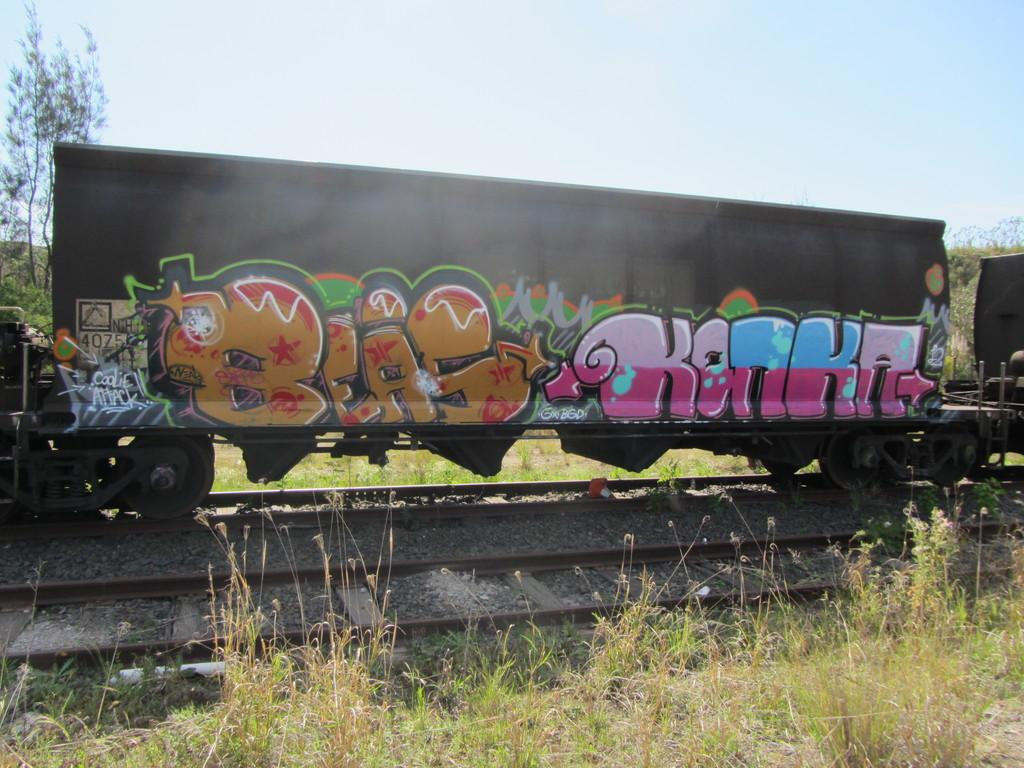What is the main subject of the image? The main subject of the image is a train. What is the train's position in the image? The train is on a track. What can be observed about the train's appearance? The train has a colorful painting on it. What type of natural environment is visible near the train? There is grass and trees next to the train. What can be seen in the background of the image? The sky is visible in the background of the image. Can you tell me what type of cap the train is wearing in the image? There is no cap present on the train in the image. How many people are pushing the train in the image? There are no people pushing the train in the image; it is on a track. 